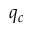Convert formula to latex. <formula><loc_0><loc_0><loc_500><loc_500>q _ { c }</formula> 